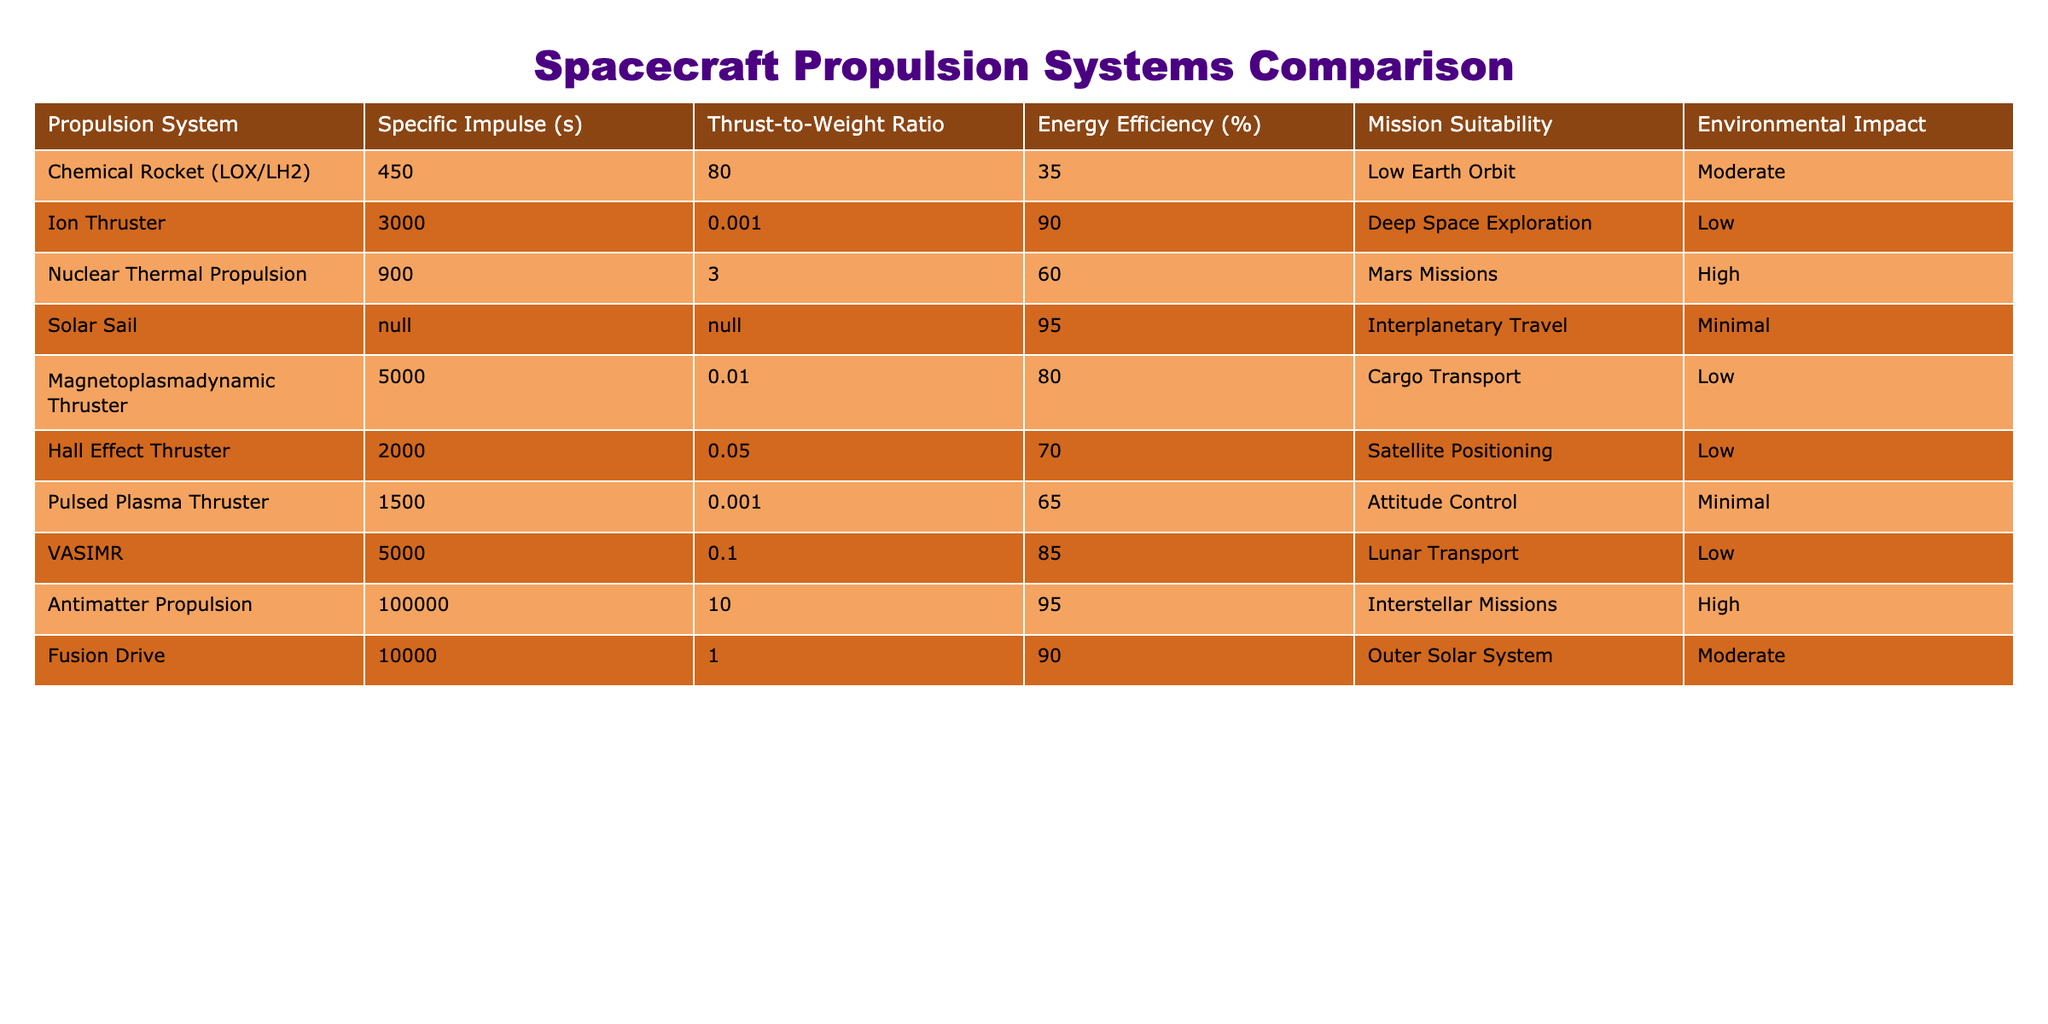What is the specific impulse of the Ion Thruster? The specific impulse is listed directly in the table for the Ion Thruster, which is 3000 seconds.
Answer: 3000 seconds Which propulsion system has the highest energy efficiency? The table shows that the Solar Sail has an energy efficiency of 95%. No other propulsion system listed has a higher percentage.
Answer: Solar Sail Is the Thrust-to-Weight Ratio of the Hall Effect Thruster greater than that of the Chemical Rocket? The Thrust-to-Weight Ratio for the Hall Effect Thruster is 0.05, while for the Chemical Rocket it is 80. Since 0.05 is less than 80, the answer is no.
Answer: No What is the average energy efficiency of all propulsion systems listed? To calculate the average, sum all energy efficiency values (35 + 90 + 60 + 95 + 80 + 70 + 65 + 85 + 95 + 90 =  805) and divide by the total number of systems (10). The average is 805/10 = 80.5%.
Answer: 80.5% How many propulsion systems have a high environmental impact? The table indicates that two propulsion systems (Nuclear Thermal Propulsion and Antimatter Propulsion) are marked as having a high environmental impact.
Answer: 2 Which propulsion system is suitable for Lunar Transport and what is its energy efficiency? From the table, the VASIMR is listed as suitable for Lunar Transport and has an energy efficiency of 85%.
Answer: VASIMR, 85% What is the difference in specific impulse between the Fusion Drive and the Antimatter Propulsion systems? The specific impulse of the Fusion Drive is 10000 seconds and that of Antimatter Propulsion is 100000 seconds. The difference is calculated as 100000 - 10000 = 90000 seconds.
Answer: 90000 seconds Are there any propulsion systems suitable for Interstellar Missions? Yes, according to the table, Antimatter Propulsion is the only system listed as suitable for Interstellar Missions, confirming the presence of such a system.
Answer: Yes Which propulsion system has the lowest thrust-to-weight ratio suitable for cargo transport? The Magnetoplasmadynamic Thruster has a thrust-to-weight ratio of 0.01, which is the lowest among the systems listed suitable for cargo transport.
Answer: Magnetoplasmadynamic Thruster 